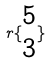<formula> <loc_0><loc_0><loc_500><loc_500>r \{ \begin{matrix} 5 \\ 3 \end{matrix} \}</formula> 